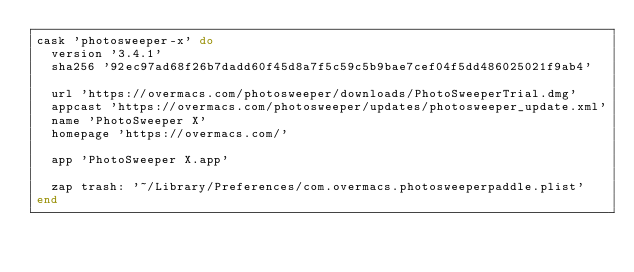Convert code to text. <code><loc_0><loc_0><loc_500><loc_500><_Ruby_>cask 'photosweeper-x' do
  version '3.4.1'
  sha256 '92ec97ad68f26b7dadd60f45d8a7f5c59c5b9bae7cef04f5dd486025021f9ab4'

  url 'https://overmacs.com/photosweeper/downloads/PhotoSweeperTrial.dmg'
  appcast 'https://overmacs.com/photosweeper/updates/photosweeper_update.xml'
  name 'PhotoSweeper X'
  homepage 'https://overmacs.com/'

  app 'PhotoSweeper X.app'

  zap trash: '~/Library/Preferences/com.overmacs.photosweeperpaddle.plist'
end
</code> 